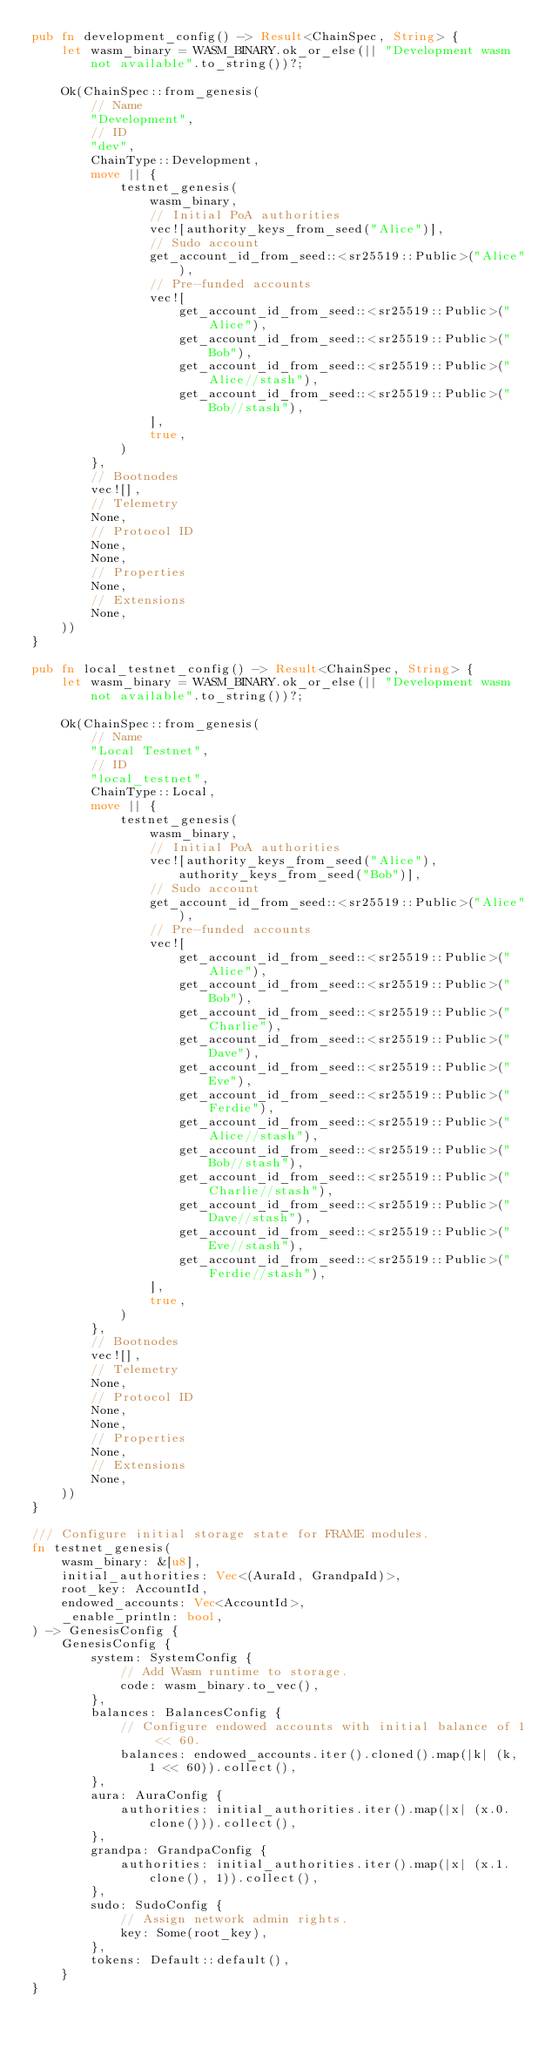<code> <loc_0><loc_0><loc_500><loc_500><_Rust_>pub fn development_config() -> Result<ChainSpec, String> {
	let wasm_binary = WASM_BINARY.ok_or_else(|| "Development wasm not available".to_string())?;

	Ok(ChainSpec::from_genesis(
		// Name
		"Development",
		// ID
		"dev",
		ChainType::Development,
		move || {
			testnet_genesis(
				wasm_binary,
				// Initial PoA authorities
				vec![authority_keys_from_seed("Alice")],
				// Sudo account
				get_account_id_from_seed::<sr25519::Public>("Alice"),
				// Pre-funded accounts
				vec![
					get_account_id_from_seed::<sr25519::Public>("Alice"),
					get_account_id_from_seed::<sr25519::Public>("Bob"),
					get_account_id_from_seed::<sr25519::Public>("Alice//stash"),
					get_account_id_from_seed::<sr25519::Public>("Bob//stash"),
				],
				true,
			)
		},
		// Bootnodes
		vec![],
		// Telemetry
		None,
		// Protocol ID
		None,
		None,
		// Properties
		None,
		// Extensions
		None,
	))
}

pub fn local_testnet_config() -> Result<ChainSpec, String> {
	let wasm_binary = WASM_BINARY.ok_or_else(|| "Development wasm not available".to_string())?;

	Ok(ChainSpec::from_genesis(
		// Name
		"Local Testnet",
		// ID
		"local_testnet",
		ChainType::Local,
		move || {
			testnet_genesis(
				wasm_binary,
				// Initial PoA authorities
				vec![authority_keys_from_seed("Alice"), authority_keys_from_seed("Bob")],
				// Sudo account
				get_account_id_from_seed::<sr25519::Public>("Alice"),
				// Pre-funded accounts
				vec![
					get_account_id_from_seed::<sr25519::Public>("Alice"),
					get_account_id_from_seed::<sr25519::Public>("Bob"),
					get_account_id_from_seed::<sr25519::Public>("Charlie"),
					get_account_id_from_seed::<sr25519::Public>("Dave"),
					get_account_id_from_seed::<sr25519::Public>("Eve"),
					get_account_id_from_seed::<sr25519::Public>("Ferdie"),
					get_account_id_from_seed::<sr25519::Public>("Alice//stash"),
					get_account_id_from_seed::<sr25519::Public>("Bob//stash"),
					get_account_id_from_seed::<sr25519::Public>("Charlie//stash"),
					get_account_id_from_seed::<sr25519::Public>("Dave//stash"),
					get_account_id_from_seed::<sr25519::Public>("Eve//stash"),
					get_account_id_from_seed::<sr25519::Public>("Ferdie//stash"),
				],
				true,
			)
		},
		// Bootnodes
		vec![],
		// Telemetry
		None,
		// Protocol ID
		None,
		None,
		// Properties
		None,
		// Extensions
		None,
	))
}

/// Configure initial storage state for FRAME modules.
fn testnet_genesis(
	wasm_binary: &[u8],
	initial_authorities: Vec<(AuraId, GrandpaId)>,
	root_key: AccountId,
	endowed_accounts: Vec<AccountId>,
	_enable_println: bool,
) -> GenesisConfig {
	GenesisConfig {
		system: SystemConfig {
			// Add Wasm runtime to storage.
			code: wasm_binary.to_vec(),
		},
		balances: BalancesConfig {
			// Configure endowed accounts with initial balance of 1 << 60.
			balances: endowed_accounts.iter().cloned().map(|k| (k, 1 << 60)).collect(),
		},
		aura: AuraConfig {
			authorities: initial_authorities.iter().map(|x| (x.0.clone())).collect(),
		},
		grandpa: GrandpaConfig {
			authorities: initial_authorities.iter().map(|x| (x.1.clone(), 1)).collect(),
		},
		sudo: SudoConfig {
			// Assign network admin rights.
			key: Some(root_key),
		},
		tokens: Default::default(),
	}
}
</code> 